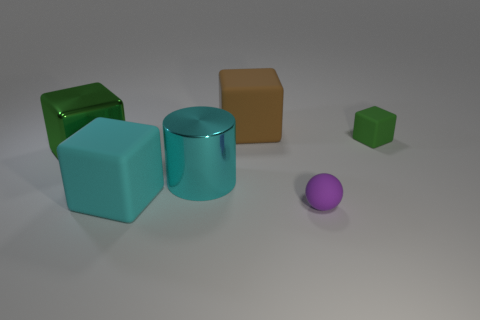How many green blocks must be subtracted to get 1 green blocks? 1 Subtract all brown rubber cubes. How many cubes are left? 3 Add 1 big red metal things. How many objects exist? 7 Subtract all green cubes. How many cubes are left? 2 Subtract all cylinders. How many objects are left? 5 Subtract 2 cubes. How many cubes are left? 2 Subtract all cyan blocks. Subtract all cyan balls. How many blocks are left? 3 Subtract all yellow cylinders. How many green cubes are left? 2 Subtract all green things. Subtract all green rubber objects. How many objects are left? 3 Add 6 purple matte balls. How many purple matte balls are left? 7 